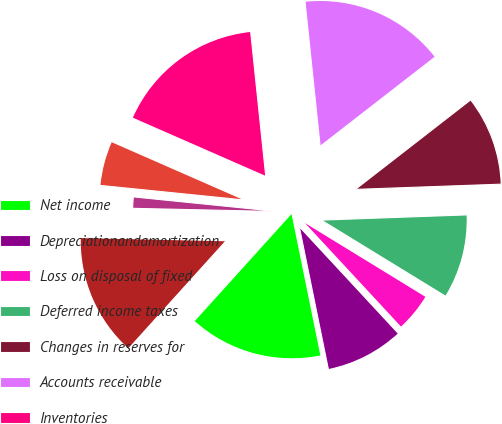<chart> <loc_0><loc_0><loc_500><loc_500><pie_chart><fcel>Net income<fcel>Depreciationandamortization<fcel>Loss on disposal of fixed<fcel>Deferred income taxes<fcel>Changes in reserves for<fcel>Accounts receivable<fcel>Inventories<fcel>Prepaid expenses and other<fcel>Other non-current assets<fcel>Accounts payable<nl><fcel>14.9%<fcel>8.7%<fcel>4.35%<fcel>9.32%<fcel>9.94%<fcel>16.15%<fcel>16.77%<fcel>4.97%<fcel>1.25%<fcel>13.66%<nl></chart> 